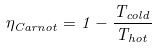<formula> <loc_0><loc_0><loc_500><loc_500>\eta _ { C a r n o t } = 1 - \frac { T _ { c o l d } } { T _ { h o t } }</formula> 